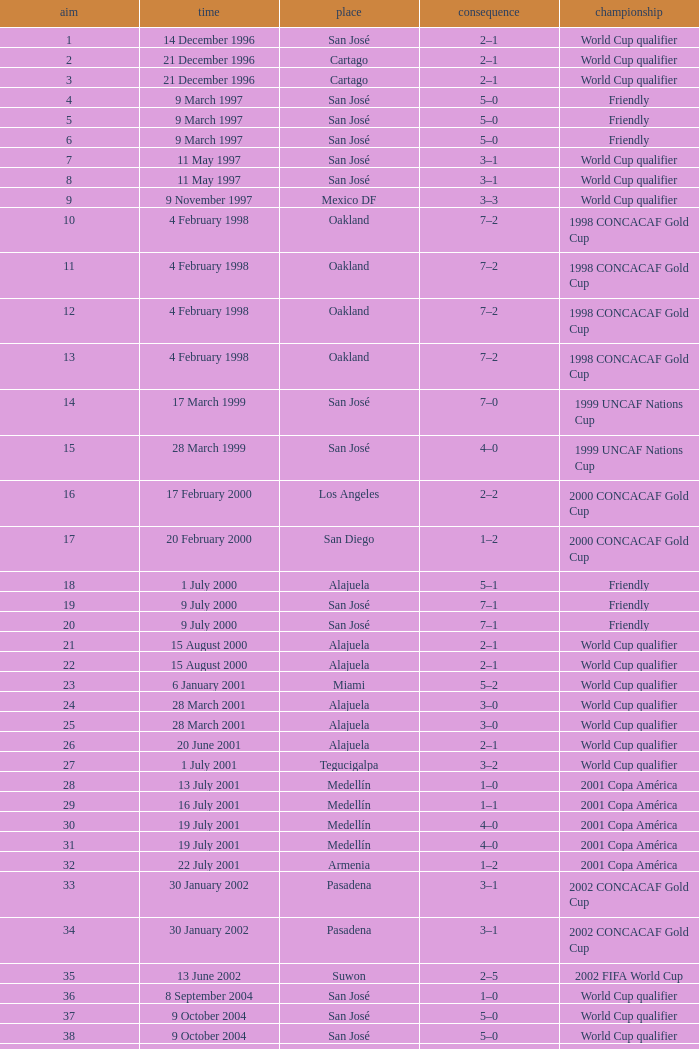What is the result in oakland? 7–2, 7–2, 7–2, 7–2. 